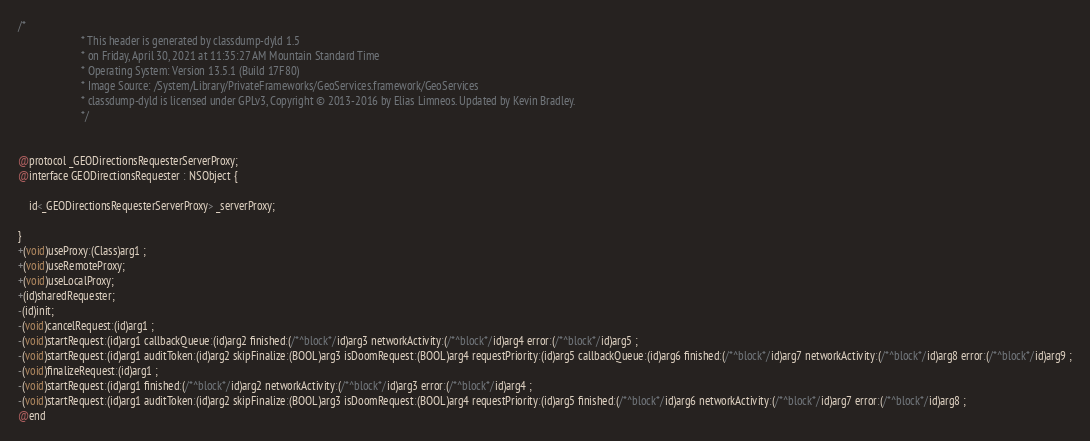Convert code to text. <code><loc_0><loc_0><loc_500><loc_500><_C_>/*
                       * This header is generated by classdump-dyld 1.5
                       * on Friday, April 30, 2021 at 11:35:27 AM Mountain Standard Time
                       * Operating System: Version 13.5.1 (Build 17F80)
                       * Image Source: /System/Library/PrivateFrameworks/GeoServices.framework/GeoServices
                       * classdump-dyld is licensed under GPLv3, Copyright © 2013-2016 by Elias Limneos. Updated by Kevin Bradley.
                       */


@protocol _GEODirectionsRequesterServerProxy;
@interface GEODirectionsRequester : NSObject {

	id<_GEODirectionsRequesterServerProxy> _serverProxy;

}
+(void)useProxy:(Class)arg1 ;
+(void)useRemoteProxy;
+(void)useLocalProxy;
+(id)sharedRequester;
-(id)init;
-(void)cancelRequest:(id)arg1 ;
-(void)startRequest:(id)arg1 callbackQueue:(id)arg2 finished:(/*^block*/id)arg3 networkActivity:(/*^block*/id)arg4 error:(/*^block*/id)arg5 ;
-(void)startRequest:(id)arg1 auditToken:(id)arg2 skipFinalize:(BOOL)arg3 isDoomRequest:(BOOL)arg4 requestPriority:(id)arg5 callbackQueue:(id)arg6 finished:(/*^block*/id)arg7 networkActivity:(/*^block*/id)arg8 error:(/*^block*/id)arg9 ;
-(void)finalizeRequest:(id)arg1 ;
-(void)startRequest:(id)arg1 finished:(/*^block*/id)arg2 networkActivity:(/*^block*/id)arg3 error:(/*^block*/id)arg4 ;
-(void)startRequest:(id)arg1 auditToken:(id)arg2 skipFinalize:(BOOL)arg3 isDoomRequest:(BOOL)arg4 requestPriority:(id)arg5 finished:(/*^block*/id)arg6 networkActivity:(/*^block*/id)arg7 error:(/*^block*/id)arg8 ;
@end

</code> 